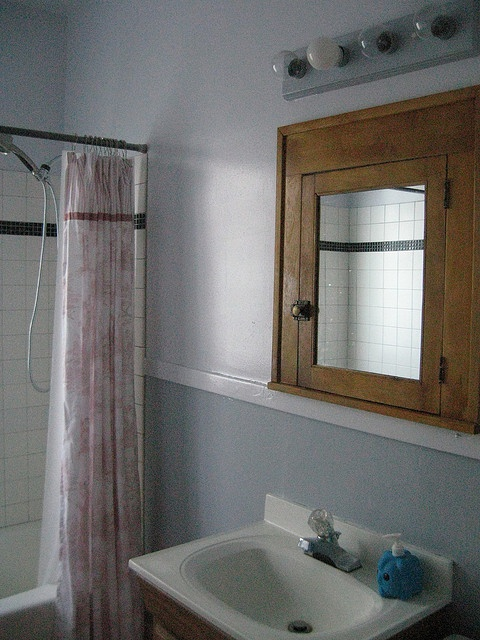Describe the objects in this image and their specific colors. I can see a sink in black and gray tones in this image. 